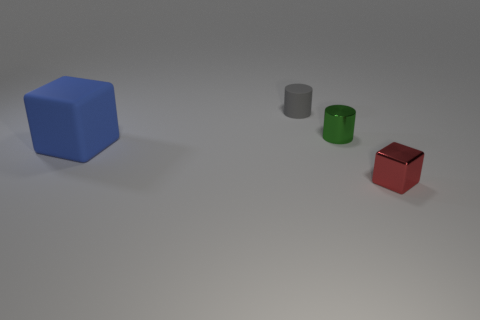What number of small things are either yellow matte cylinders or blue matte things?
Give a very brief answer. 0. There is a thing that is right of the shiny thing that is left of the small red object; are there any things to the left of it?
Keep it short and to the point. Yes. Is there a matte cylinder of the same size as the red object?
Keep it short and to the point. Yes. What material is the gray thing that is the same size as the red cube?
Make the answer very short. Rubber. Do the green cylinder and the matte thing that is on the right side of the large blue rubber cube have the same size?
Ensure brevity in your answer.  Yes. How many rubber things are either tiny blocks or blocks?
Give a very brief answer. 1. How many other blue objects have the same shape as the small matte thing?
Ensure brevity in your answer.  0. Is the size of the rubber thing that is in front of the small gray cylinder the same as the metallic thing on the left side of the small red cube?
Provide a succinct answer. No. The matte thing that is in front of the tiny gray object has what shape?
Provide a short and direct response. Cube. There is another small object that is the same shape as the blue rubber object; what is its material?
Ensure brevity in your answer.  Metal. 